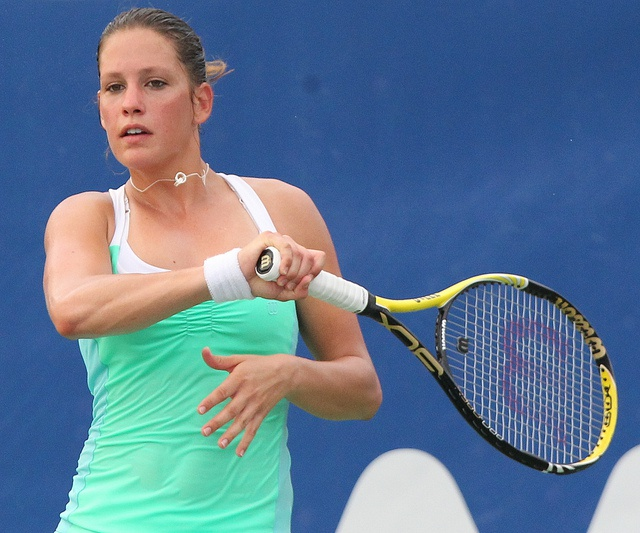Describe the objects in this image and their specific colors. I can see people in blue, tan, turquoise, brown, and aquamarine tones and tennis racket in blue, gray, black, and darkgray tones in this image. 